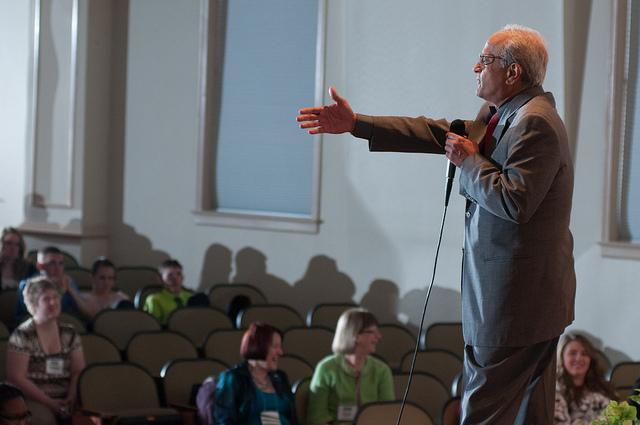How many people are wearing green shirts?
Give a very brief answer. 2. How many people are in the photo?
Give a very brief answer. 6. How many chairs can you see?
Give a very brief answer. 4. How many skis are being used?
Give a very brief answer. 0. 